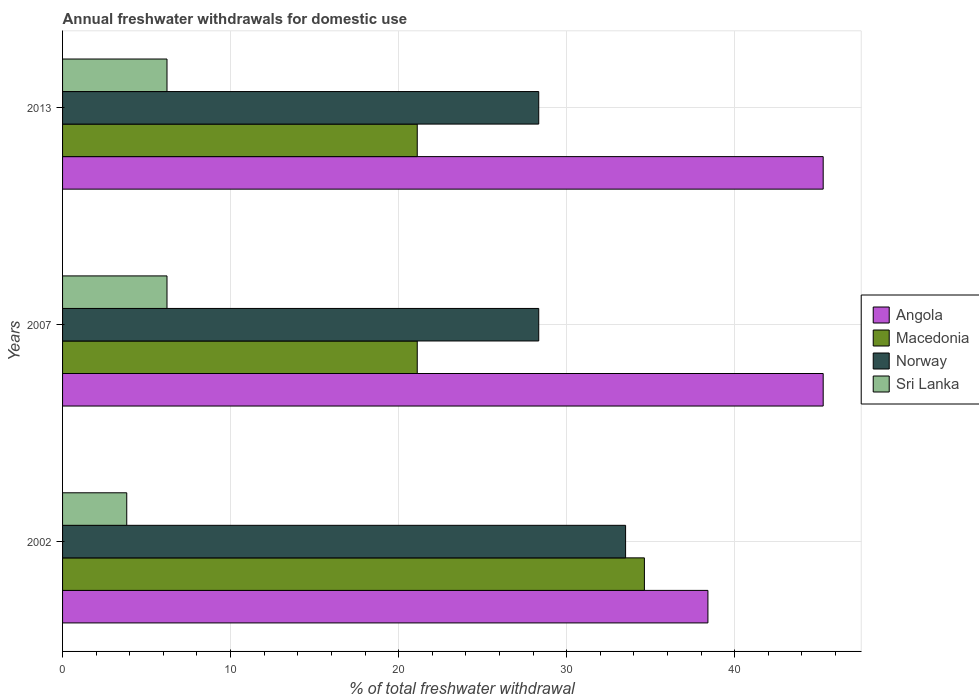How many different coloured bars are there?
Your response must be concise. 4. How many groups of bars are there?
Offer a terse response. 3. Are the number of bars per tick equal to the number of legend labels?
Ensure brevity in your answer.  Yes. Are the number of bars on each tick of the Y-axis equal?
Give a very brief answer. Yes. How many bars are there on the 1st tick from the top?
Keep it short and to the point. 4. How many bars are there on the 1st tick from the bottom?
Keep it short and to the point. 4. What is the label of the 3rd group of bars from the top?
Make the answer very short. 2002. What is the total annual withdrawals from freshwater in Sri Lanka in 2007?
Provide a short and direct response. 6.22. Across all years, what is the maximum total annual withdrawals from freshwater in Angola?
Make the answer very short. 45.27. Across all years, what is the minimum total annual withdrawals from freshwater in Norway?
Your response must be concise. 28.34. In which year was the total annual withdrawals from freshwater in Norway maximum?
Give a very brief answer. 2002. In which year was the total annual withdrawals from freshwater in Angola minimum?
Give a very brief answer. 2002. What is the total total annual withdrawals from freshwater in Angola in the graph?
Offer a terse response. 128.95. What is the difference between the total annual withdrawals from freshwater in Sri Lanka in 2002 and that in 2007?
Make the answer very short. -2.4. What is the difference between the total annual withdrawals from freshwater in Angola in 2007 and the total annual withdrawals from freshwater in Sri Lanka in 2002?
Your answer should be compact. 41.45. What is the average total annual withdrawals from freshwater in Macedonia per year?
Give a very brief answer. 25.62. In the year 2002, what is the difference between the total annual withdrawals from freshwater in Sri Lanka and total annual withdrawals from freshwater in Angola?
Your answer should be compact. -34.59. What is the ratio of the total annual withdrawals from freshwater in Norway in 2007 to that in 2013?
Make the answer very short. 1. What is the difference between the highest and the second highest total annual withdrawals from freshwater in Norway?
Provide a short and direct response. 5.17. What is the difference between the highest and the lowest total annual withdrawals from freshwater in Sri Lanka?
Offer a very short reply. 2.4. In how many years, is the total annual withdrawals from freshwater in Macedonia greater than the average total annual withdrawals from freshwater in Macedonia taken over all years?
Give a very brief answer. 1. Is it the case that in every year, the sum of the total annual withdrawals from freshwater in Sri Lanka and total annual withdrawals from freshwater in Macedonia is greater than the sum of total annual withdrawals from freshwater in Angola and total annual withdrawals from freshwater in Norway?
Your answer should be very brief. No. What does the 1st bar from the top in 2002 represents?
Your response must be concise. Sri Lanka. What does the 3rd bar from the bottom in 2007 represents?
Provide a succinct answer. Norway. Is it the case that in every year, the sum of the total annual withdrawals from freshwater in Angola and total annual withdrawals from freshwater in Macedonia is greater than the total annual withdrawals from freshwater in Norway?
Your answer should be very brief. Yes. How many bars are there?
Make the answer very short. 12. Are all the bars in the graph horizontal?
Offer a very short reply. Yes. Does the graph contain any zero values?
Provide a short and direct response. No. Does the graph contain grids?
Provide a succinct answer. Yes. Where does the legend appear in the graph?
Your response must be concise. Center right. How many legend labels are there?
Offer a terse response. 4. How are the legend labels stacked?
Your answer should be very brief. Vertical. What is the title of the graph?
Offer a very short reply. Annual freshwater withdrawals for domestic use. Does "Croatia" appear as one of the legend labels in the graph?
Provide a succinct answer. No. What is the label or title of the X-axis?
Provide a succinct answer. % of total freshwater withdrawal. What is the label or title of the Y-axis?
Your answer should be very brief. Years. What is the % of total freshwater withdrawal in Angola in 2002?
Provide a short and direct response. 38.41. What is the % of total freshwater withdrawal of Macedonia in 2002?
Give a very brief answer. 34.63. What is the % of total freshwater withdrawal of Norway in 2002?
Provide a succinct answer. 33.51. What is the % of total freshwater withdrawal in Sri Lanka in 2002?
Make the answer very short. 3.82. What is the % of total freshwater withdrawal in Angola in 2007?
Provide a succinct answer. 45.27. What is the % of total freshwater withdrawal in Macedonia in 2007?
Make the answer very short. 21.11. What is the % of total freshwater withdrawal of Norway in 2007?
Your answer should be compact. 28.34. What is the % of total freshwater withdrawal in Sri Lanka in 2007?
Provide a succinct answer. 6.22. What is the % of total freshwater withdrawal in Angola in 2013?
Your response must be concise. 45.27. What is the % of total freshwater withdrawal of Macedonia in 2013?
Offer a terse response. 21.11. What is the % of total freshwater withdrawal in Norway in 2013?
Your answer should be very brief. 28.34. What is the % of total freshwater withdrawal in Sri Lanka in 2013?
Make the answer very short. 6.22. Across all years, what is the maximum % of total freshwater withdrawal of Angola?
Ensure brevity in your answer.  45.27. Across all years, what is the maximum % of total freshwater withdrawal in Macedonia?
Make the answer very short. 34.63. Across all years, what is the maximum % of total freshwater withdrawal in Norway?
Give a very brief answer. 33.51. Across all years, what is the maximum % of total freshwater withdrawal of Sri Lanka?
Ensure brevity in your answer.  6.22. Across all years, what is the minimum % of total freshwater withdrawal of Angola?
Offer a terse response. 38.41. Across all years, what is the minimum % of total freshwater withdrawal of Macedonia?
Ensure brevity in your answer.  21.11. Across all years, what is the minimum % of total freshwater withdrawal in Norway?
Offer a very short reply. 28.34. Across all years, what is the minimum % of total freshwater withdrawal in Sri Lanka?
Provide a succinct answer. 3.82. What is the total % of total freshwater withdrawal in Angola in the graph?
Provide a succinct answer. 128.95. What is the total % of total freshwater withdrawal of Macedonia in the graph?
Your response must be concise. 76.85. What is the total % of total freshwater withdrawal in Norway in the graph?
Give a very brief answer. 90.19. What is the total % of total freshwater withdrawal of Sri Lanka in the graph?
Your response must be concise. 16.25. What is the difference between the % of total freshwater withdrawal of Angola in 2002 and that in 2007?
Keep it short and to the point. -6.86. What is the difference between the % of total freshwater withdrawal in Macedonia in 2002 and that in 2007?
Ensure brevity in your answer.  13.52. What is the difference between the % of total freshwater withdrawal of Norway in 2002 and that in 2007?
Keep it short and to the point. 5.17. What is the difference between the % of total freshwater withdrawal of Sri Lanka in 2002 and that in 2007?
Your answer should be very brief. -2.4. What is the difference between the % of total freshwater withdrawal of Angola in 2002 and that in 2013?
Ensure brevity in your answer.  -6.86. What is the difference between the % of total freshwater withdrawal of Macedonia in 2002 and that in 2013?
Offer a very short reply. 13.52. What is the difference between the % of total freshwater withdrawal of Norway in 2002 and that in 2013?
Ensure brevity in your answer.  5.17. What is the difference between the % of total freshwater withdrawal in Sri Lanka in 2002 and that in 2013?
Your response must be concise. -2.4. What is the difference between the % of total freshwater withdrawal in Angola in 2007 and that in 2013?
Make the answer very short. 0. What is the difference between the % of total freshwater withdrawal of Macedonia in 2007 and that in 2013?
Give a very brief answer. 0. What is the difference between the % of total freshwater withdrawal in Norway in 2007 and that in 2013?
Provide a succinct answer. 0. What is the difference between the % of total freshwater withdrawal of Angola in 2002 and the % of total freshwater withdrawal of Macedonia in 2007?
Your answer should be very brief. 17.3. What is the difference between the % of total freshwater withdrawal of Angola in 2002 and the % of total freshwater withdrawal of Norway in 2007?
Ensure brevity in your answer.  10.07. What is the difference between the % of total freshwater withdrawal of Angola in 2002 and the % of total freshwater withdrawal of Sri Lanka in 2007?
Your response must be concise. 32.19. What is the difference between the % of total freshwater withdrawal of Macedonia in 2002 and the % of total freshwater withdrawal of Norway in 2007?
Your response must be concise. 6.29. What is the difference between the % of total freshwater withdrawal in Macedonia in 2002 and the % of total freshwater withdrawal in Sri Lanka in 2007?
Your answer should be compact. 28.41. What is the difference between the % of total freshwater withdrawal of Norway in 2002 and the % of total freshwater withdrawal of Sri Lanka in 2007?
Make the answer very short. 27.29. What is the difference between the % of total freshwater withdrawal of Angola in 2002 and the % of total freshwater withdrawal of Macedonia in 2013?
Your answer should be compact. 17.3. What is the difference between the % of total freshwater withdrawal of Angola in 2002 and the % of total freshwater withdrawal of Norway in 2013?
Your answer should be very brief. 10.07. What is the difference between the % of total freshwater withdrawal in Angola in 2002 and the % of total freshwater withdrawal in Sri Lanka in 2013?
Your answer should be compact. 32.19. What is the difference between the % of total freshwater withdrawal in Macedonia in 2002 and the % of total freshwater withdrawal in Norway in 2013?
Provide a short and direct response. 6.29. What is the difference between the % of total freshwater withdrawal of Macedonia in 2002 and the % of total freshwater withdrawal of Sri Lanka in 2013?
Provide a short and direct response. 28.41. What is the difference between the % of total freshwater withdrawal of Norway in 2002 and the % of total freshwater withdrawal of Sri Lanka in 2013?
Your answer should be compact. 27.29. What is the difference between the % of total freshwater withdrawal in Angola in 2007 and the % of total freshwater withdrawal in Macedonia in 2013?
Your response must be concise. 24.16. What is the difference between the % of total freshwater withdrawal of Angola in 2007 and the % of total freshwater withdrawal of Norway in 2013?
Provide a short and direct response. 16.93. What is the difference between the % of total freshwater withdrawal of Angola in 2007 and the % of total freshwater withdrawal of Sri Lanka in 2013?
Provide a short and direct response. 39.05. What is the difference between the % of total freshwater withdrawal of Macedonia in 2007 and the % of total freshwater withdrawal of Norway in 2013?
Offer a terse response. -7.23. What is the difference between the % of total freshwater withdrawal in Macedonia in 2007 and the % of total freshwater withdrawal in Sri Lanka in 2013?
Offer a terse response. 14.89. What is the difference between the % of total freshwater withdrawal in Norway in 2007 and the % of total freshwater withdrawal in Sri Lanka in 2013?
Provide a short and direct response. 22.12. What is the average % of total freshwater withdrawal of Angola per year?
Offer a terse response. 42.98. What is the average % of total freshwater withdrawal of Macedonia per year?
Provide a succinct answer. 25.62. What is the average % of total freshwater withdrawal in Norway per year?
Offer a very short reply. 30.06. What is the average % of total freshwater withdrawal in Sri Lanka per year?
Ensure brevity in your answer.  5.42. In the year 2002, what is the difference between the % of total freshwater withdrawal in Angola and % of total freshwater withdrawal in Macedonia?
Offer a terse response. 3.78. In the year 2002, what is the difference between the % of total freshwater withdrawal in Angola and % of total freshwater withdrawal in Norway?
Keep it short and to the point. 4.9. In the year 2002, what is the difference between the % of total freshwater withdrawal of Angola and % of total freshwater withdrawal of Sri Lanka?
Your response must be concise. 34.59. In the year 2002, what is the difference between the % of total freshwater withdrawal of Macedonia and % of total freshwater withdrawal of Norway?
Your answer should be very brief. 1.12. In the year 2002, what is the difference between the % of total freshwater withdrawal of Macedonia and % of total freshwater withdrawal of Sri Lanka?
Ensure brevity in your answer.  30.81. In the year 2002, what is the difference between the % of total freshwater withdrawal of Norway and % of total freshwater withdrawal of Sri Lanka?
Your response must be concise. 29.69. In the year 2007, what is the difference between the % of total freshwater withdrawal of Angola and % of total freshwater withdrawal of Macedonia?
Offer a very short reply. 24.16. In the year 2007, what is the difference between the % of total freshwater withdrawal in Angola and % of total freshwater withdrawal in Norway?
Ensure brevity in your answer.  16.93. In the year 2007, what is the difference between the % of total freshwater withdrawal in Angola and % of total freshwater withdrawal in Sri Lanka?
Provide a short and direct response. 39.05. In the year 2007, what is the difference between the % of total freshwater withdrawal in Macedonia and % of total freshwater withdrawal in Norway?
Offer a terse response. -7.23. In the year 2007, what is the difference between the % of total freshwater withdrawal of Macedonia and % of total freshwater withdrawal of Sri Lanka?
Ensure brevity in your answer.  14.89. In the year 2007, what is the difference between the % of total freshwater withdrawal of Norway and % of total freshwater withdrawal of Sri Lanka?
Your answer should be compact. 22.12. In the year 2013, what is the difference between the % of total freshwater withdrawal of Angola and % of total freshwater withdrawal of Macedonia?
Your answer should be compact. 24.16. In the year 2013, what is the difference between the % of total freshwater withdrawal in Angola and % of total freshwater withdrawal in Norway?
Your answer should be very brief. 16.93. In the year 2013, what is the difference between the % of total freshwater withdrawal of Angola and % of total freshwater withdrawal of Sri Lanka?
Ensure brevity in your answer.  39.05. In the year 2013, what is the difference between the % of total freshwater withdrawal in Macedonia and % of total freshwater withdrawal in Norway?
Make the answer very short. -7.23. In the year 2013, what is the difference between the % of total freshwater withdrawal in Macedonia and % of total freshwater withdrawal in Sri Lanka?
Make the answer very short. 14.89. In the year 2013, what is the difference between the % of total freshwater withdrawal in Norway and % of total freshwater withdrawal in Sri Lanka?
Your answer should be compact. 22.12. What is the ratio of the % of total freshwater withdrawal in Angola in 2002 to that in 2007?
Ensure brevity in your answer.  0.85. What is the ratio of the % of total freshwater withdrawal of Macedonia in 2002 to that in 2007?
Give a very brief answer. 1.64. What is the ratio of the % of total freshwater withdrawal in Norway in 2002 to that in 2007?
Your answer should be compact. 1.18. What is the ratio of the % of total freshwater withdrawal of Sri Lanka in 2002 to that in 2007?
Give a very brief answer. 0.61. What is the ratio of the % of total freshwater withdrawal of Angola in 2002 to that in 2013?
Your answer should be very brief. 0.85. What is the ratio of the % of total freshwater withdrawal of Macedonia in 2002 to that in 2013?
Ensure brevity in your answer.  1.64. What is the ratio of the % of total freshwater withdrawal in Norway in 2002 to that in 2013?
Offer a very short reply. 1.18. What is the ratio of the % of total freshwater withdrawal in Sri Lanka in 2002 to that in 2013?
Keep it short and to the point. 0.61. What is the ratio of the % of total freshwater withdrawal of Norway in 2007 to that in 2013?
Make the answer very short. 1. What is the difference between the highest and the second highest % of total freshwater withdrawal in Macedonia?
Give a very brief answer. 13.52. What is the difference between the highest and the second highest % of total freshwater withdrawal of Norway?
Provide a succinct answer. 5.17. What is the difference between the highest and the lowest % of total freshwater withdrawal of Angola?
Provide a short and direct response. 6.86. What is the difference between the highest and the lowest % of total freshwater withdrawal of Macedonia?
Provide a succinct answer. 13.52. What is the difference between the highest and the lowest % of total freshwater withdrawal of Norway?
Offer a terse response. 5.17. What is the difference between the highest and the lowest % of total freshwater withdrawal of Sri Lanka?
Keep it short and to the point. 2.4. 